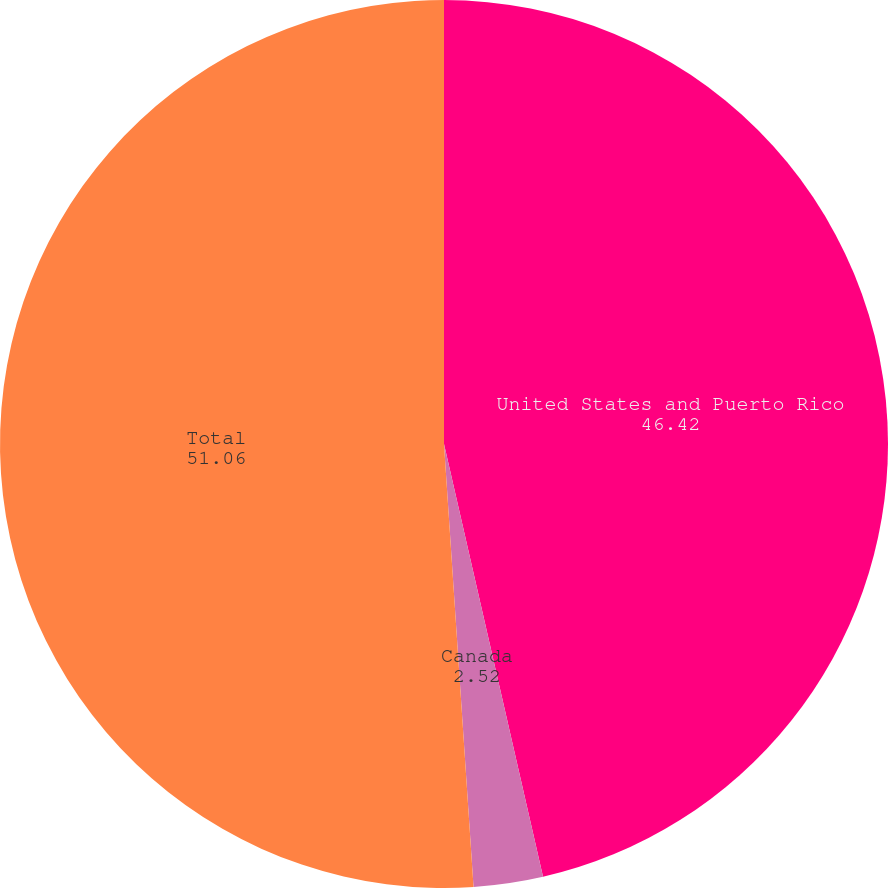<chart> <loc_0><loc_0><loc_500><loc_500><pie_chart><fcel>United States and Puerto Rico<fcel>Canada<fcel>Total<nl><fcel>46.42%<fcel>2.52%<fcel>51.06%<nl></chart> 